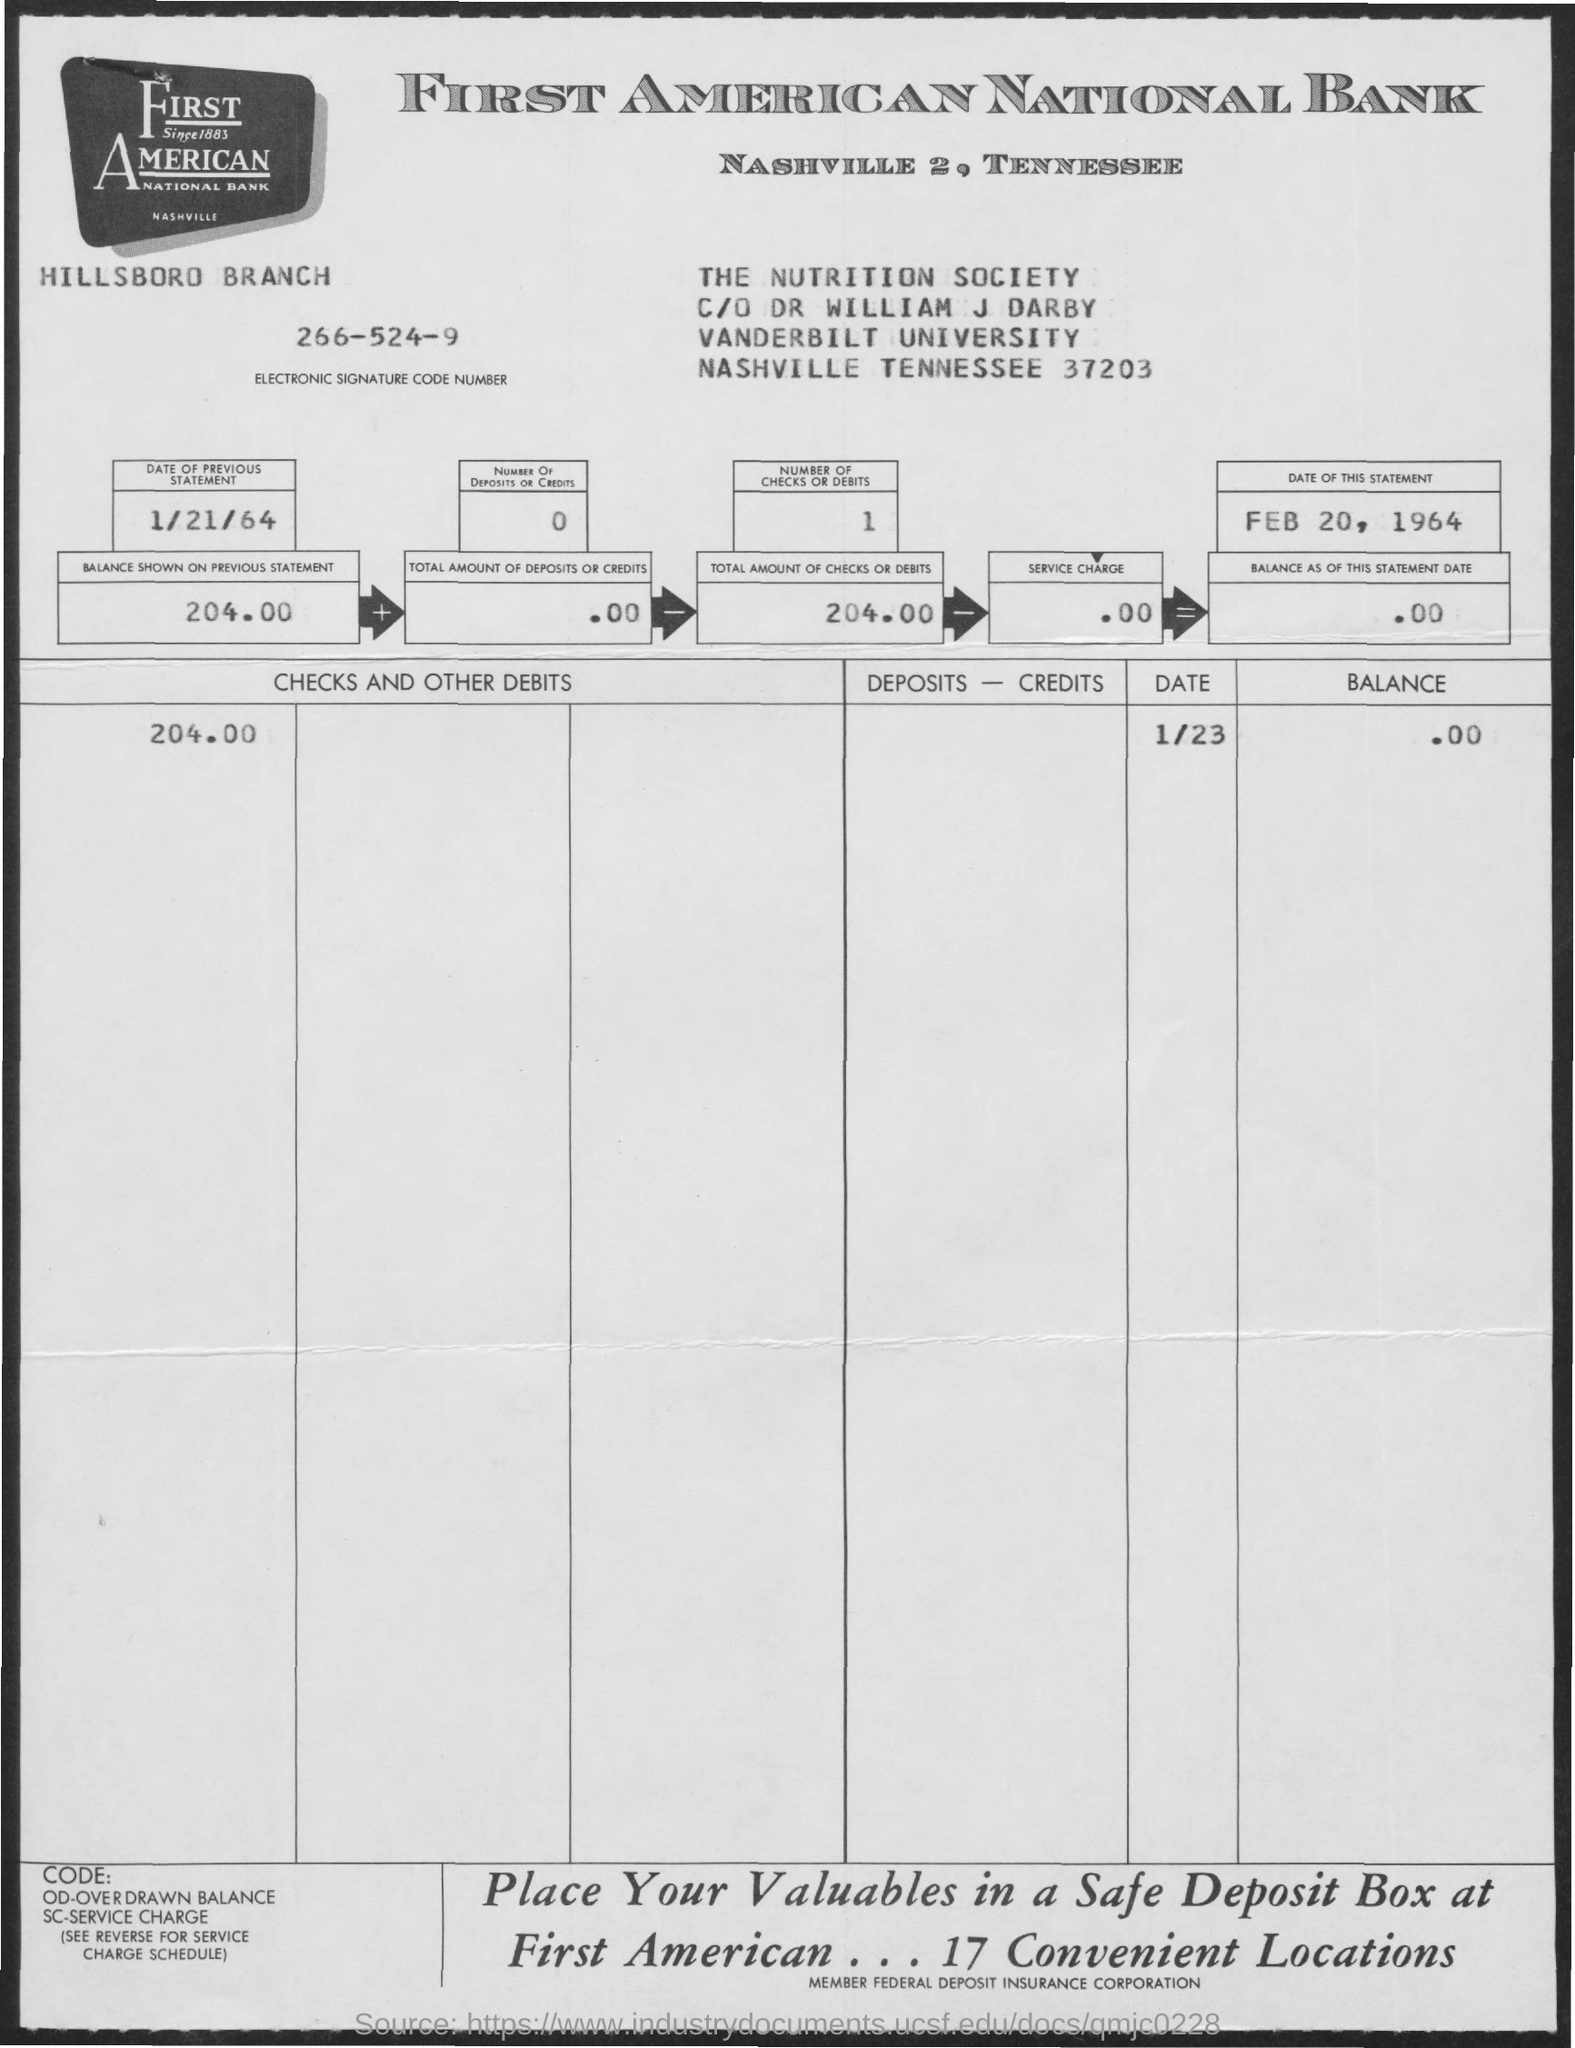What is the Electronic Signature Code Number given in the statement? The Electronic Signature Code Number provided in the bank statement is 266-524-9, which is unique to this particular account at the Hillsboro Branch of First American National Bank in Nashville, Tennessee. 